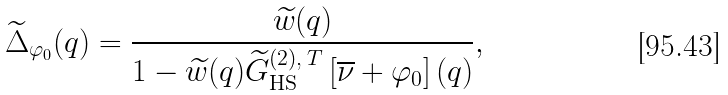<formula> <loc_0><loc_0><loc_500><loc_500>\widetilde { \Delta } _ { \varphi _ { 0 } } ( q ) = \frac { \widetilde { w } ( q ) } { 1 - \widetilde { w } ( q ) \widetilde { G } _ { \text {HS} } ^ { ( 2 ) , \, T } \left [ \overline { \nu } + \varphi _ { 0 } \right ] ( q ) } ,</formula> 